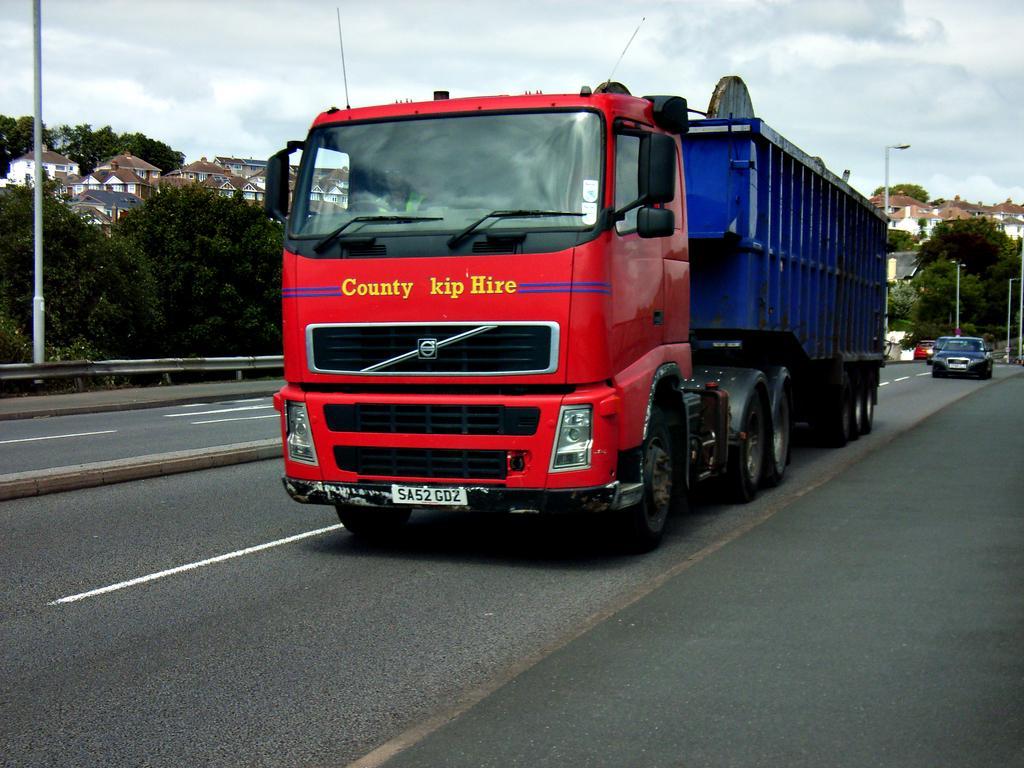In one or two sentences, can you explain what this image depicts? In this image, we can see a truck is moving on the road. Here we can see a person is inside the vehicle. Background we can see trees, houses, poles, vehicles, road. Top of the image, there is a cloudy sky. 